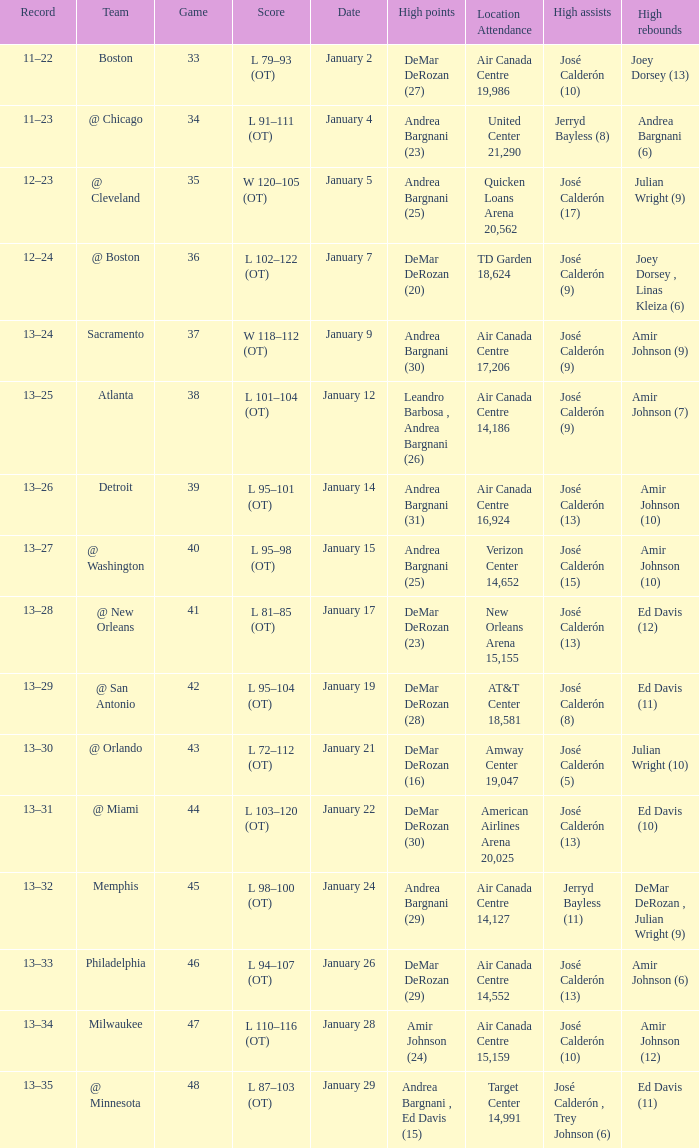Name the number of high rebounds for january 5 1.0. 